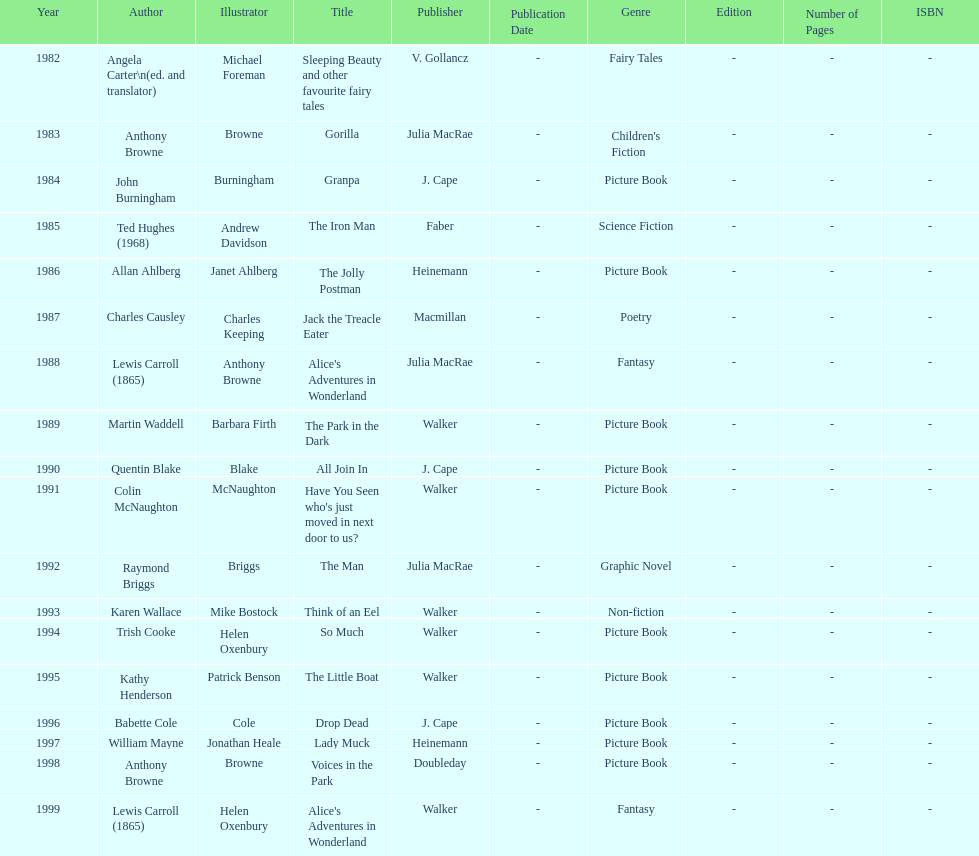Which illustrator was responsible for the last award winner? Helen Oxenbury. 